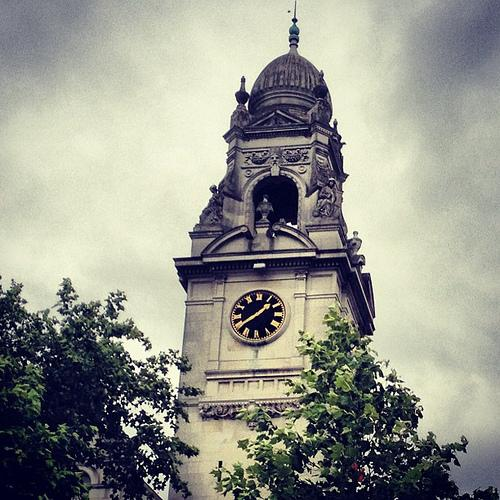Mention the type of numeral used on the clocks in the image and indicate the color of the clock hands. The clocks use Roman numerals and have gold-colored clock hands. What is the building's material and what are some architectural features of the tower? The building is made of stone, and the tower has an arch, a spire, a dome, engravings, statues, and angels. Describe the relationship between the trees and the tower in the image. The trees are growing alongside and in front of the tower, and the tower is taller than the trees. Describe the general setting and atmosphere of the picture. The picture is taken outside during the day, featuring a cloudy sky, green trees, and an old, ornate clock tower. How would you describe the state in which the trees in the image are? The trees are green, full of leaves, and growing in front of the tower. What are some characteristics of the sky in the image? The sky is grey, cloudy, and the dark blue is peeking through the clouds. What time is displayed on the large clock with golden numbers? The time displayed on the clock is 1:40. Mention two objects that are part of the tower's decoration and their position. A statue and a face carved into the stone are part of the tower's decoration, both located above an arched opening. How can the clouds in the image be described in terms of color? The clouds are grey and white. What is the comparative height of the tower and the trees observed in the image? The tower is taller than the trees. Is the sky a bright blue color? The sky in the image is described as grey, cloudy, and with dark blue sky peeking through clouds, but not as a bright blue color. Identify the primary object in the image. A large clock tower Are there any green clouds in the sky? The clouds are described as grey and white, but not green. So the presence of green clouds in the sky is not accurate. Is the clock tower made of glass? The clock tower is described as stone, ornate, and grey, but not made of glass. So the material of the clock tower as glass is not accurate. What type of mood does the image convey with its colors and atmosphere? A cloudy and serene day What time does the clock in the image display? 1:40 What do the numerals on the clock face represent? Roman numerals Is there a statue of a horse on the clock tower? No, it's not mentioned in the image. Describe the color and texture of the sky in the image. The sky is grey and cloudy. What can be seen above the arched opening on the clock tower? A face Are the leaves on the tree a vibrant shade of orange? The leaves on the tree are described as green, not orange, which suggests that they are not a vibrant shade of orange. Is the statue close to the clock hands or atop the tower? Close to the clock hands Does the clock display the time as 12:45? The clock in the image is said to read either 139 or 140, not 12:45. So the given time is not accurate. Explain the three primary subjects or objects within the image. A tall clock tower, a green leafy tree, and a grey cloudy sky. If the tower represents an activity or event, what could it be? Timekeeping or historical landmark Write a poetic caption for the image that emphasizes the tall clock tower and serene atmosphere. "Ancient clock tower pierces heavens, green trees sway in harmony beneath the dreamy grey curtain of clouds." What type of weather is present in the image? Cloudy Which features of the clock tower can be considered as ornate and elaborate? Engravings, statues, arch, face in the stone, and cathedral roof. Write a descriptive caption that emphasizes the clock tower, the sky, and the tree. "A towering stone clock marking 1:40, nestled amongst a verdant canopy of trees while a dance of grey clouds ensues above." What does the clouds in the sky say about the weather? Cloudy and possibly overcast. Are the clock hands in the image black or gold in color? Gold Create a caption for the image that combines information about the cloudy sky, clock tower, and tree. "A majestic clock tower stands tall behind luscious green trees under a cloudy grey sky." What color is the building made of stone? Grey Based on the image, what is the ratio of the height of the tower to the height of the tree? The tower is taller than the tree. Describe the overall atmosphere and setting of the image. An old clock tower behind green trees on a cloudy day. 